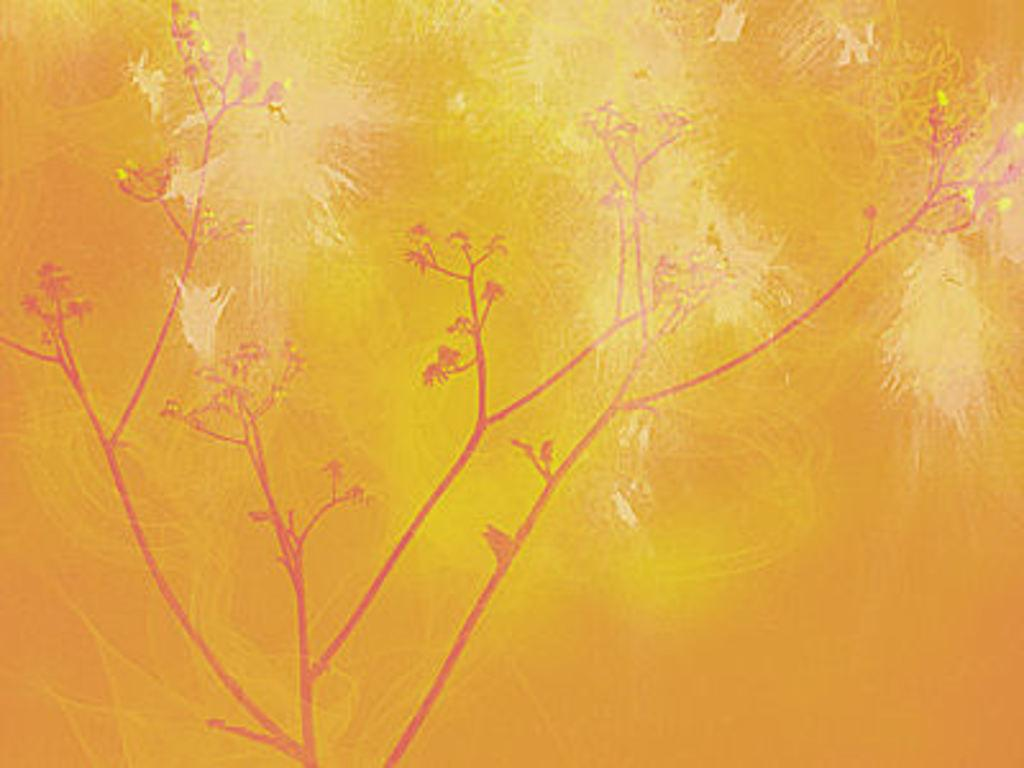What is the main subject of the image? The main subject of the image is a painting. What elements are included in the painting? The painting contains a tree and birds. What type of nut is depicted in the painting? There is no nut depicted in the painting; it contains a tree and birds. How much payment is required to purchase the painting in the image? The image does not provide information about the cost or payment required to purchase the painting. 